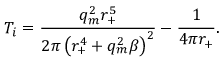Convert formula to latex. <formula><loc_0><loc_0><loc_500><loc_500>T _ { i } = \frac { q _ { m } ^ { 2 } r _ { + } ^ { 5 } } { 2 \pi \left ( r _ { + } ^ { 4 } + q _ { m } ^ { 2 } \beta \right ) ^ { 2 } } - \frac { 1 } { 4 \pi r _ { + } } .</formula> 